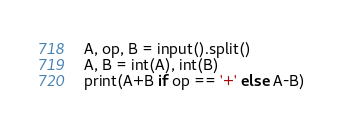<code> <loc_0><loc_0><loc_500><loc_500><_Python_>A, op, B = input().split()
A, B = int(A), int(B)
print(A+B if op == '+' else A-B)</code> 